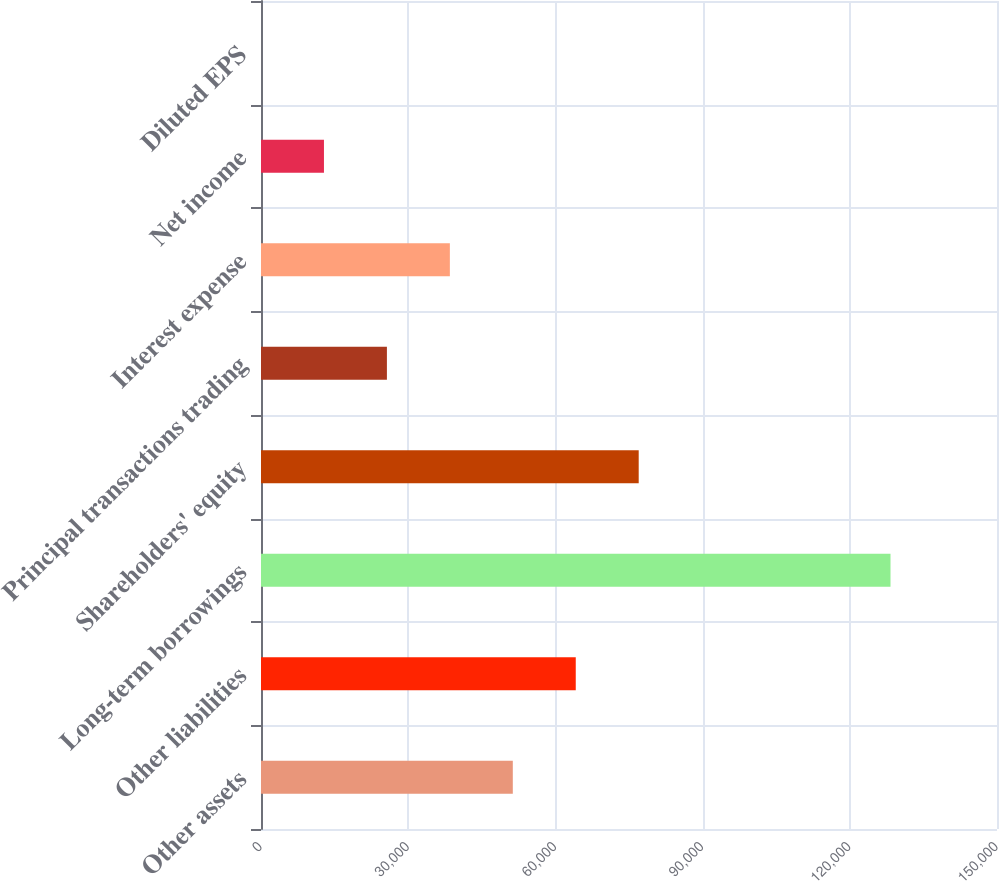Convert chart to OTSL. <chart><loc_0><loc_0><loc_500><loc_500><bar_chart><fcel>Other assets<fcel>Other liabilities<fcel>Long-term borrowings<fcel>Shareholders' equity<fcel>Principal transactions trading<fcel>Interest expense<fcel>Net income<fcel>Diluted EPS<nl><fcel>51319.5<fcel>64148.9<fcel>128296<fcel>76978.3<fcel>25660.6<fcel>38490<fcel>12831.2<fcel>1.75<nl></chart> 